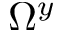Convert formula to latex. <formula><loc_0><loc_0><loc_500><loc_500>\Omega ^ { y }</formula> 